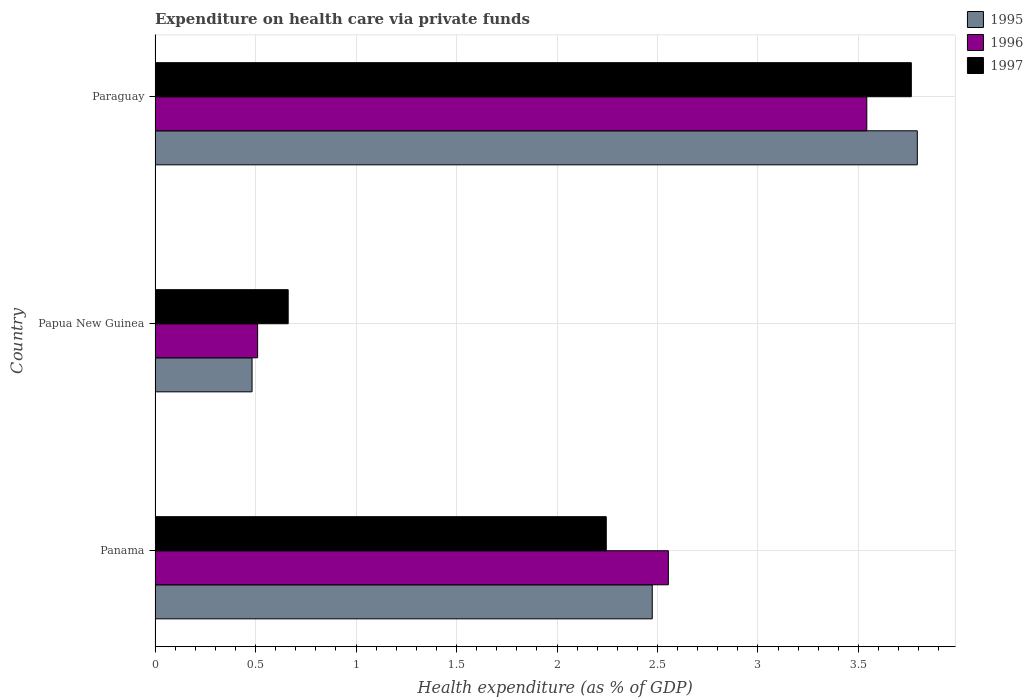How many different coloured bars are there?
Offer a terse response. 3. Are the number of bars per tick equal to the number of legend labels?
Keep it short and to the point. Yes. What is the label of the 3rd group of bars from the top?
Provide a succinct answer. Panama. In how many cases, is the number of bars for a given country not equal to the number of legend labels?
Your answer should be compact. 0. What is the expenditure made on health care in 1997 in Papua New Guinea?
Give a very brief answer. 0.66. Across all countries, what is the maximum expenditure made on health care in 1996?
Your answer should be very brief. 3.54. Across all countries, what is the minimum expenditure made on health care in 1997?
Ensure brevity in your answer.  0.66. In which country was the expenditure made on health care in 1995 maximum?
Provide a short and direct response. Paraguay. In which country was the expenditure made on health care in 1995 minimum?
Offer a very short reply. Papua New Guinea. What is the total expenditure made on health care in 1995 in the graph?
Ensure brevity in your answer.  6.75. What is the difference between the expenditure made on health care in 1996 in Papua New Guinea and that in Paraguay?
Offer a terse response. -3.03. What is the difference between the expenditure made on health care in 1996 in Papua New Guinea and the expenditure made on health care in 1995 in Paraguay?
Provide a succinct answer. -3.28. What is the average expenditure made on health care in 1997 per country?
Ensure brevity in your answer.  2.22. What is the difference between the expenditure made on health care in 1996 and expenditure made on health care in 1997 in Paraguay?
Your answer should be compact. -0.22. In how many countries, is the expenditure made on health care in 1995 greater than 3.1 %?
Offer a very short reply. 1. What is the ratio of the expenditure made on health care in 1996 in Papua New Guinea to that in Paraguay?
Your response must be concise. 0.14. Is the expenditure made on health care in 1996 in Papua New Guinea less than that in Paraguay?
Your answer should be very brief. Yes. What is the difference between the highest and the second highest expenditure made on health care in 1997?
Provide a succinct answer. 1.52. What is the difference between the highest and the lowest expenditure made on health care in 1995?
Provide a short and direct response. 3.31. In how many countries, is the expenditure made on health care in 1997 greater than the average expenditure made on health care in 1997 taken over all countries?
Offer a terse response. 2. Is the sum of the expenditure made on health care in 1995 in Panama and Papua New Guinea greater than the maximum expenditure made on health care in 1997 across all countries?
Offer a very short reply. No. What does the 2nd bar from the bottom in Paraguay represents?
Your answer should be very brief. 1996. Are all the bars in the graph horizontal?
Offer a very short reply. Yes. How many countries are there in the graph?
Your answer should be compact. 3. Does the graph contain any zero values?
Your response must be concise. No. Does the graph contain grids?
Provide a short and direct response. Yes. Where does the legend appear in the graph?
Offer a very short reply. Top right. How are the legend labels stacked?
Provide a short and direct response. Vertical. What is the title of the graph?
Provide a short and direct response. Expenditure on health care via private funds. What is the label or title of the X-axis?
Provide a succinct answer. Health expenditure (as % of GDP). What is the Health expenditure (as % of GDP) in 1995 in Panama?
Make the answer very short. 2.47. What is the Health expenditure (as % of GDP) of 1996 in Panama?
Your answer should be compact. 2.55. What is the Health expenditure (as % of GDP) in 1997 in Panama?
Ensure brevity in your answer.  2.25. What is the Health expenditure (as % of GDP) in 1995 in Papua New Guinea?
Provide a short and direct response. 0.48. What is the Health expenditure (as % of GDP) of 1996 in Papua New Guinea?
Offer a very short reply. 0.51. What is the Health expenditure (as % of GDP) in 1997 in Papua New Guinea?
Ensure brevity in your answer.  0.66. What is the Health expenditure (as % of GDP) of 1995 in Paraguay?
Provide a succinct answer. 3.79. What is the Health expenditure (as % of GDP) of 1996 in Paraguay?
Provide a short and direct response. 3.54. What is the Health expenditure (as % of GDP) of 1997 in Paraguay?
Provide a succinct answer. 3.76. Across all countries, what is the maximum Health expenditure (as % of GDP) of 1995?
Offer a very short reply. 3.79. Across all countries, what is the maximum Health expenditure (as % of GDP) in 1996?
Your response must be concise. 3.54. Across all countries, what is the maximum Health expenditure (as % of GDP) in 1997?
Your answer should be compact. 3.76. Across all countries, what is the minimum Health expenditure (as % of GDP) of 1995?
Make the answer very short. 0.48. Across all countries, what is the minimum Health expenditure (as % of GDP) of 1996?
Provide a succinct answer. 0.51. Across all countries, what is the minimum Health expenditure (as % of GDP) of 1997?
Keep it short and to the point. 0.66. What is the total Health expenditure (as % of GDP) in 1995 in the graph?
Your response must be concise. 6.75. What is the total Health expenditure (as % of GDP) of 1996 in the graph?
Offer a very short reply. 6.61. What is the total Health expenditure (as % of GDP) of 1997 in the graph?
Make the answer very short. 6.67. What is the difference between the Health expenditure (as % of GDP) in 1995 in Panama and that in Papua New Guinea?
Give a very brief answer. 1.99. What is the difference between the Health expenditure (as % of GDP) of 1996 in Panama and that in Papua New Guinea?
Keep it short and to the point. 2.04. What is the difference between the Health expenditure (as % of GDP) of 1997 in Panama and that in Papua New Guinea?
Provide a short and direct response. 1.58. What is the difference between the Health expenditure (as % of GDP) of 1995 in Panama and that in Paraguay?
Provide a short and direct response. -1.32. What is the difference between the Health expenditure (as % of GDP) of 1996 in Panama and that in Paraguay?
Give a very brief answer. -0.99. What is the difference between the Health expenditure (as % of GDP) of 1997 in Panama and that in Paraguay?
Keep it short and to the point. -1.52. What is the difference between the Health expenditure (as % of GDP) in 1995 in Papua New Guinea and that in Paraguay?
Your response must be concise. -3.31. What is the difference between the Health expenditure (as % of GDP) in 1996 in Papua New Guinea and that in Paraguay?
Your response must be concise. -3.03. What is the difference between the Health expenditure (as % of GDP) of 1997 in Papua New Guinea and that in Paraguay?
Your answer should be very brief. -3.1. What is the difference between the Health expenditure (as % of GDP) of 1995 in Panama and the Health expenditure (as % of GDP) of 1996 in Papua New Guinea?
Your answer should be very brief. 1.96. What is the difference between the Health expenditure (as % of GDP) in 1995 in Panama and the Health expenditure (as % of GDP) in 1997 in Papua New Guinea?
Offer a very short reply. 1.81. What is the difference between the Health expenditure (as % of GDP) of 1996 in Panama and the Health expenditure (as % of GDP) of 1997 in Papua New Guinea?
Provide a short and direct response. 1.89. What is the difference between the Health expenditure (as % of GDP) in 1995 in Panama and the Health expenditure (as % of GDP) in 1996 in Paraguay?
Ensure brevity in your answer.  -1.07. What is the difference between the Health expenditure (as % of GDP) of 1995 in Panama and the Health expenditure (as % of GDP) of 1997 in Paraguay?
Your response must be concise. -1.29. What is the difference between the Health expenditure (as % of GDP) of 1996 in Panama and the Health expenditure (as % of GDP) of 1997 in Paraguay?
Keep it short and to the point. -1.21. What is the difference between the Health expenditure (as % of GDP) of 1995 in Papua New Guinea and the Health expenditure (as % of GDP) of 1996 in Paraguay?
Your response must be concise. -3.06. What is the difference between the Health expenditure (as % of GDP) of 1995 in Papua New Guinea and the Health expenditure (as % of GDP) of 1997 in Paraguay?
Offer a terse response. -3.28. What is the difference between the Health expenditure (as % of GDP) of 1996 in Papua New Guinea and the Health expenditure (as % of GDP) of 1997 in Paraguay?
Your answer should be very brief. -3.25. What is the average Health expenditure (as % of GDP) of 1995 per country?
Keep it short and to the point. 2.25. What is the average Health expenditure (as % of GDP) of 1996 per country?
Your answer should be very brief. 2.2. What is the average Health expenditure (as % of GDP) of 1997 per country?
Offer a very short reply. 2.22. What is the difference between the Health expenditure (as % of GDP) in 1995 and Health expenditure (as % of GDP) in 1996 in Panama?
Keep it short and to the point. -0.08. What is the difference between the Health expenditure (as % of GDP) in 1995 and Health expenditure (as % of GDP) in 1997 in Panama?
Your response must be concise. 0.23. What is the difference between the Health expenditure (as % of GDP) of 1996 and Health expenditure (as % of GDP) of 1997 in Panama?
Your response must be concise. 0.31. What is the difference between the Health expenditure (as % of GDP) in 1995 and Health expenditure (as % of GDP) in 1996 in Papua New Guinea?
Give a very brief answer. -0.03. What is the difference between the Health expenditure (as % of GDP) of 1995 and Health expenditure (as % of GDP) of 1997 in Papua New Guinea?
Offer a terse response. -0.18. What is the difference between the Health expenditure (as % of GDP) in 1996 and Health expenditure (as % of GDP) in 1997 in Papua New Guinea?
Make the answer very short. -0.15. What is the difference between the Health expenditure (as % of GDP) of 1995 and Health expenditure (as % of GDP) of 1996 in Paraguay?
Make the answer very short. 0.25. What is the difference between the Health expenditure (as % of GDP) in 1995 and Health expenditure (as % of GDP) in 1997 in Paraguay?
Provide a short and direct response. 0.03. What is the difference between the Health expenditure (as % of GDP) in 1996 and Health expenditure (as % of GDP) in 1997 in Paraguay?
Ensure brevity in your answer.  -0.22. What is the ratio of the Health expenditure (as % of GDP) of 1995 in Panama to that in Papua New Guinea?
Provide a succinct answer. 5.13. What is the ratio of the Health expenditure (as % of GDP) of 1996 in Panama to that in Papua New Guinea?
Make the answer very short. 5. What is the ratio of the Health expenditure (as % of GDP) in 1997 in Panama to that in Papua New Guinea?
Offer a very short reply. 3.39. What is the ratio of the Health expenditure (as % of GDP) in 1995 in Panama to that in Paraguay?
Keep it short and to the point. 0.65. What is the ratio of the Health expenditure (as % of GDP) of 1996 in Panama to that in Paraguay?
Your response must be concise. 0.72. What is the ratio of the Health expenditure (as % of GDP) in 1997 in Panama to that in Paraguay?
Your response must be concise. 0.6. What is the ratio of the Health expenditure (as % of GDP) in 1995 in Papua New Guinea to that in Paraguay?
Your answer should be very brief. 0.13. What is the ratio of the Health expenditure (as % of GDP) in 1996 in Papua New Guinea to that in Paraguay?
Your answer should be very brief. 0.14. What is the ratio of the Health expenditure (as % of GDP) of 1997 in Papua New Guinea to that in Paraguay?
Offer a very short reply. 0.18. What is the difference between the highest and the second highest Health expenditure (as % of GDP) in 1995?
Your answer should be compact. 1.32. What is the difference between the highest and the second highest Health expenditure (as % of GDP) of 1996?
Provide a short and direct response. 0.99. What is the difference between the highest and the second highest Health expenditure (as % of GDP) in 1997?
Give a very brief answer. 1.52. What is the difference between the highest and the lowest Health expenditure (as % of GDP) of 1995?
Make the answer very short. 3.31. What is the difference between the highest and the lowest Health expenditure (as % of GDP) of 1996?
Provide a short and direct response. 3.03. What is the difference between the highest and the lowest Health expenditure (as % of GDP) of 1997?
Offer a terse response. 3.1. 